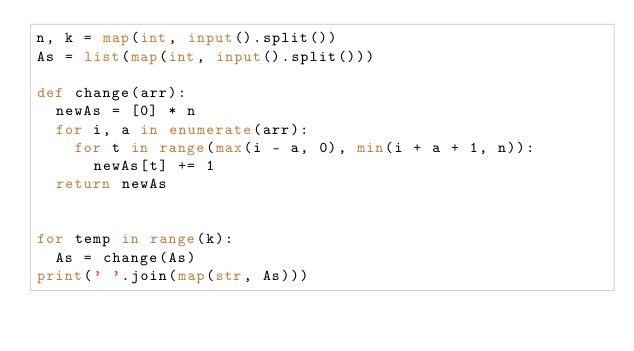Convert code to text. <code><loc_0><loc_0><loc_500><loc_500><_Python_>n, k = map(int, input().split())
As = list(map(int, input().split()))

def change(arr):
  newAs = [0] * n
  for i, a in enumerate(arr):
    for t in range(max(i - a, 0), min(i + a + 1, n)):
      newAs[t] += 1
  return newAs


for temp in range(k):
  As = change(As)
print(' '.join(map(str, As)))</code> 